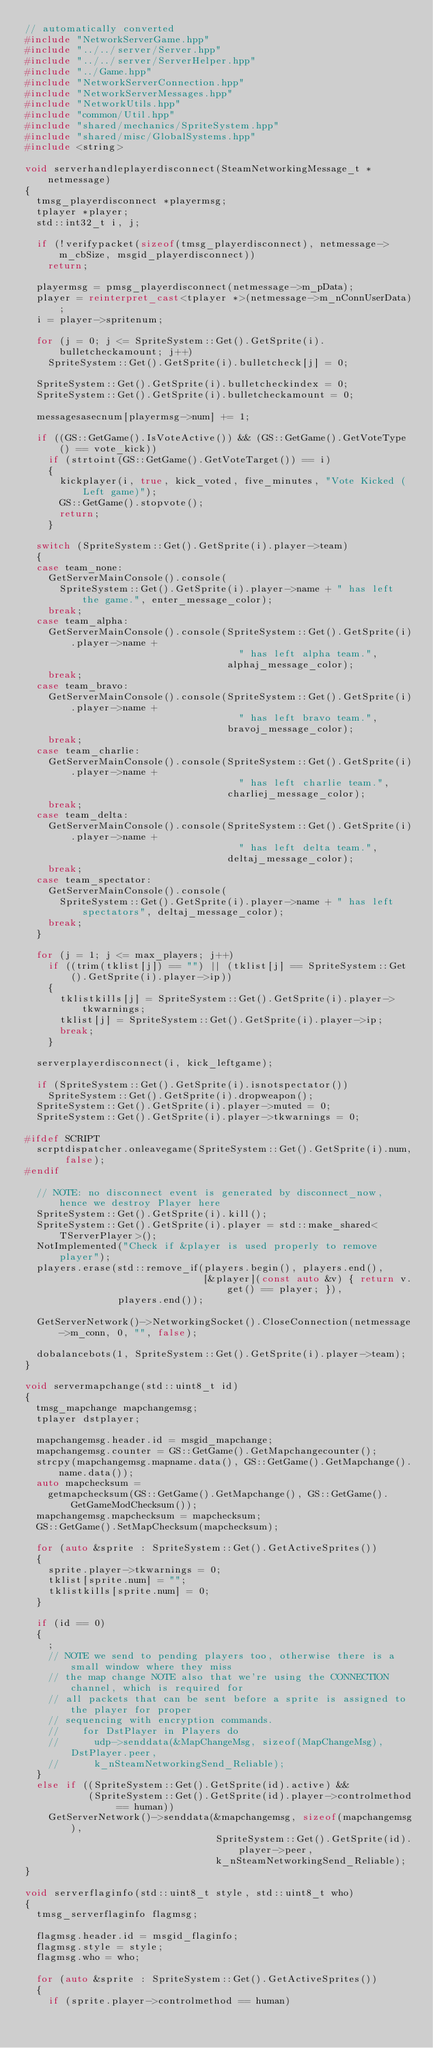<code> <loc_0><loc_0><loc_500><loc_500><_C++_>// automatically converted
#include "NetworkServerGame.hpp"
#include "../../server/Server.hpp"
#include "../../server/ServerHelper.hpp"
#include "../Game.hpp"
#include "NetworkServerConnection.hpp"
#include "NetworkServerMessages.hpp"
#include "NetworkUtils.hpp"
#include "common/Util.hpp"
#include "shared/mechanics/SpriteSystem.hpp"
#include "shared/misc/GlobalSystems.hpp"
#include <string>

void serverhandleplayerdisconnect(SteamNetworkingMessage_t *netmessage)
{
  tmsg_playerdisconnect *playermsg;
  tplayer *player;
  std::int32_t i, j;

  if (!verifypacket(sizeof(tmsg_playerdisconnect), netmessage->m_cbSize, msgid_playerdisconnect))
    return;

  playermsg = pmsg_playerdisconnect(netmessage->m_pData);
  player = reinterpret_cast<tplayer *>(netmessage->m_nConnUserData);
  i = player->spritenum;

  for (j = 0; j <= SpriteSystem::Get().GetSprite(i).bulletcheckamount; j++)
    SpriteSystem::Get().GetSprite(i).bulletcheck[j] = 0;

  SpriteSystem::Get().GetSprite(i).bulletcheckindex = 0;
  SpriteSystem::Get().GetSprite(i).bulletcheckamount = 0;

  messagesasecnum[playermsg->num] += 1;

  if ((GS::GetGame().IsVoteActive()) && (GS::GetGame().GetVoteType() == vote_kick))
    if (strtoint(GS::GetGame().GetVoteTarget()) == i)
    {
      kickplayer(i, true, kick_voted, five_minutes, "Vote Kicked (Left game)");
      GS::GetGame().stopvote();
      return;
    }

  switch (SpriteSystem::Get().GetSprite(i).player->team)
  {
  case team_none:
    GetServerMainConsole().console(
      SpriteSystem::Get().GetSprite(i).player->name + " has left the game.", enter_message_color);
    break;
  case team_alpha:
    GetServerMainConsole().console(SpriteSystem::Get().GetSprite(i).player->name +
                                     " has left alpha team.",
                                   alphaj_message_color);
    break;
  case team_bravo:
    GetServerMainConsole().console(SpriteSystem::Get().GetSprite(i).player->name +
                                     " has left bravo team.",
                                   bravoj_message_color);
    break;
  case team_charlie:
    GetServerMainConsole().console(SpriteSystem::Get().GetSprite(i).player->name +
                                     " has left charlie team.",
                                   charliej_message_color);
    break;
  case team_delta:
    GetServerMainConsole().console(SpriteSystem::Get().GetSprite(i).player->name +
                                     " has left delta team.",
                                   deltaj_message_color);
    break;
  case team_spectator:
    GetServerMainConsole().console(
      SpriteSystem::Get().GetSprite(i).player->name + " has left spectators", deltaj_message_color);
    break;
  }

  for (j = 1; j <= max_players; j++)
    if ((trim(tklist[j]) == "") || (tklist[j] == SpriteSystem::Get().GetSprite(i).player->ip))
    {
      tklistkills[j] = SpriteSystem::Get().GetSprite(i).player->tkwarnings;
      tklist[j] = SpriteSystem::Get().GetSprite(i).player->ip;
      break;
    }

  serverplayerdisconnect(i, kick_leftgame);

  if (SpriteSystem::Get().GetSprite(i).isnotspectator())
    SpriteSystem::Get().GetSprite(i).dropweapon();
  SpriteSystem::Get().GetSprite(i).player->muted = 0;
  SpriteSystem::Get().GetSprite(i).player->tkwarnings = 0;

#ifdef SCRIPT
  scrptdispatcher.onleavegame(SpriteSystem::Get().GetSprite(i).num, false);
#endif

  // NOTE: no disconnect event is generated by disconnect_now, hence we destroy Player here
  SpriteSystem::Get().GetSprite(i).kill();
  SpriteSystem::Get().GetSprite(i).player = std::make_shared<TServerPlayer>();
  NotImplemented("Check if &player is used properly to remove player");
  players.erase(std::remove_if(players.begin(), players.end(),
                               [&player](const auto &v) { return v.get() == player; }),
                players.end());

  GetServerNetwork()->NetworkingSocket().CloseConnection(netmessage->m_conn, 0, "", false);

  dobalancebots(1, SpriteSystem::Get().GetSprite(i).player->team);
}

void servermapchange(std::uint8_t id)
{
  tmsg_mapchange mapchangemsg;
  tplayer dstplayer;

  mapchangemsg.header.id = msgid_mapchange;
  mapchangemsg.counter = GS::GetGame().GetMapchangecounter();
  strcpy(mapchangemsg.mapname.data(), GS::GetGame().GetMapchange().name.data());
  auto mapchecksum =
    getmapchecksum(GS::GetGame().GetMapchange(), GS::GetGame().GetGameModChecksum());
  mapchangemsg.mapchecksum = mapchecksum;
  GS::GetGame().SetMapChecksum(mapchecksum);

  for (auto &sprite : SpriteSystem::Get().GetActiveSprites())
  {
    sprite.player->tkwarnings = 0;
    tklist[sprite.num] = "";
    tklistkills[sprite.num] = 0;
  }

  if (id == 0)
  {
    ;
    // NOTE we send to pending players too, otherwise there is a small window where they miss
    // the map change NOTE also that we're using the CONNECTION channel, which is required for
    // all packets that can be sent before a sprite is assigned to the player for proper
    // sequencing with encryption commands.
    //    for DstPlayer in Players do
    //      udp->senddata(&MapChangeMsg, sizeof(MapChangeMsg), DstPlayer.peer,
    //      k_nSteamNetworkingSend_Reliable);
  }
  else if ((SpriteSystem::Get().GetSprite(id).active) &&
           (SpriteSystem::Get().GetSprite(id).player->controlmethod == human))
    GetServerNetwork()->senddata(&mapchangemsg, sizeof(mapchangemsg),
                                 SpriteSystem::Get().GetSprite(id).player->peer,
                                 k_nSteamNetworkingSend_Reliable);
}

void serverflaginfo(std::uint8_t style, std::uint8_t who)
{
  tmsg_serverflaginfo flagmsg;

  flagmsg.header.id = msgid_flaginfo;
  flagmsg.style = style;
  flagmsg.who = who;

  for (auto &sprite : SpriteSystem::Get().GetActiveSprites())
  {
    if (sprite.player->controlmethod == human)</code> 